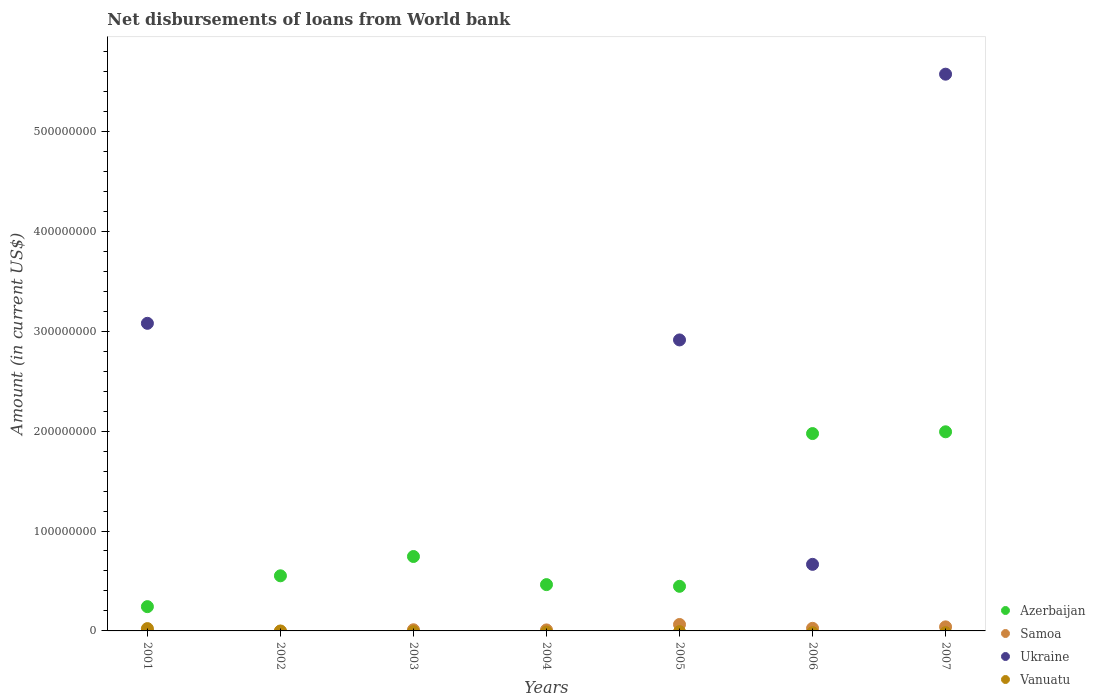What is the amount of loan disbursed from World Bank in Samoa in 2005?
Keep it short and to the point. 6.44e+06. Across all years, what is the maximum amount of loan disbursed from World Bank in Samoa?
Make the answer very short. 6.44e+06. Across all years, what is the minimum amount of loan disbursed from World Bank in Azerbaijan?
Your answer should be very brief. 2.43e+07. In which year was the amount of loan disbursed from World Bank in Vanuatu maximum?
Keep it short and to the point. 2001. What is the total amount of loan disbursed from World Bank in Vanuatu in the graph?
Offer a very short reply. 2.32e+06. What is the difference between the amount of loan disbursed from World Bank in Samoa in 2001 and that in 2007?
Provide a short and direct response. -3.95e+06. What is the difference between the amount of loan disbursed from World Bank in Samoa in 2006 and the amount of loan disbursed from World Bank in Vanuatu in 2001?
Ensure brevity in your answer.  2.75e+05. What is the average amount of loan disbursed from World Bank in Azerbaijan per year?
Make the answer very short. 9.17e+07. In the year 2001, what is the difference between the amount of loan disbursed from World Bank in Vanuatu and amount of loan disbursed from World Bank in Ukraine?
Give a very brief answer. -3.06e+08. In how many years, is the amount of loan disbursed from World Bank in Samoa greater than 360000000 US$?
Offer a terse response. 0. What is the ratio of the amount of loan disbursed from World Bank in Azerbaijan in 2004 to that in 2005?
Your answer should be compact. 1.04. What is the difference between the highest and the second highest amount of loan disbursed from World Bank in Azerbaijan?
Your answer should be compact. 1.77e+06. What is the difference between the highest and the lowest amount of loan disbursed from World Bank in Ukraine?
Provide a succinct answer. 5.57e+08. Is it the case that in every year, the sum of the amount of loan disbursed from World Bank in Ukraine and amount of loan disbursed from World Bank in Samoa  is greater than the sum of amount of loan disbursed from World Bank in Vanuatu and amount of loan disbursed from World Bank in Azerbaijan?
Offer a terse response. No. Is the amount of loan disbursed from World Bank in Samoa strictly less than the amount of loan disbursed from World Bank in Ukraine over the years?
Provide a short and direct response. No. How many dotlines are there?
Offer a terse response. 4. How many years are there in the graph?
Ensure brevity in your answer.  7. What is the difference between two consecutive major ticks on the Y-axis?
Your response must be concise. 1.00e+08. Where does the legend appear in the graph?
Give a very brief answer. Bottom right. How many legend labels are there?
Keep it short and to the point. 4. What is the title of the graph?
Your answer should be compact. Net disbursements of loans from World bank. Does "Guatemala" appear as one of the legend labels in the graph?
Keep it short and to the point. No. What is the label or title of the X-axis?
Keep it short and to the point. Years. What is the Amount (in current US$) of Azerbaijan in 2001?
Offer a terse response. 2.43e+07. What is the Amount (in current US$) of Samoa in 2001?
Give a very brief answer. 1.08e+05. What is the Amount (in current US$) in Ukraine in 2001?
Make the answer very short. 3.08e+08. What is the Amount (in current US$) of Vanuatu in 2001?
Provide a succinct answer. 2.32e+06. What is the Amount (in current US$) of Azerbaijan in 2002?
Keep it short and to the point. 5.52e+07. What is the Amount (in current US$) in Samoa in 2002?
Keep it short and to the point. 0. What is the Amount (in current US$) in Vanuatu in 2002?
Keep it short and to the point. 0. What is the Amount (in current US$) in Azerbaijan in 2003?
Keep it short and to the point. 7.45e+07. What is the Amount (in current US$) in Samoa in 2003?
Offer a very short reply. 1.15e+06. What is the Amount (in current US$) of Ukraine in 2003?
Provide a short and direct response. 0. What is the Amount (in current US$) in Vanuatu in 2003?
Make the answer very short. 0. What is the Amount (in current US$) in Azerbaijan in 2004?
Your answer should be very brief. 4.63e+07. What is the Amount (in current US$) in Samoa in 2004?
Your response must be concise. 1.01e+06. What is the Amount (in current US$) in Ukraine in 2004?
Give a very brief answer. 0. What is the Amount (in current US$) in Vanuatu in 2004?
Provide a short and direct response. 0. What is the Amount (in current US$) of Azerbaijan in 2005?
Give a very brief answer. 4.46e+07. What is the Amount (in current US$) in Samoa in 2005?
Offer a very short reply. 6.44e+06. What is the Amount (in current US$) of Ukraine in 2005?
Offer a terse response. 2.91e+08. What is the Amount (in current US$) in Azerbaijan in 2006?
Provide a succinct answer. 1.98e+08. What is the Amount (in current US$) of Samoa in 2006?
Make the answer very short. 2.60e+06. What is the Amount (in current US$) of Ukraine in 2006?
Your answer should be compact. 6.66e+07. What is the Amount (in current US$) of Vanuatu in 2006?
Your answer should be very brief. 0. What is the Amount (in current US$) of Azerbaijan in 2007?
Your response must be concise. 1.99e+08. What is the Amount (in current US$) in Samoa in 2007?
Your answer should be compact. 4.06e+06. What is the Amount (in current US$) of Ukraine in 2007?
Your answer should be compact. 5.57e+08. Across all years, what is the maximum Amount (in current US$) in Azerbaijan?
Your response must be concise. 1.99e+08. Across all years, what is the maximum Amount (in current US$) of Samoa?
Provide a succinct answer. 6.44e+06. Across all years, what is the maximum Amount (in current US$) in Ukraine?
Make the answer very short. 5.57e+08. Across all years, what is the maximum Amount (in current US$) in Vanuatu?
Provide a succinct answer. 2.32e+06. Across all years, what is the minimum Amount (in current US$) in Azerbaijan?
Your answer should be compact. 2.43e+07. Across all years, what is the minimum Amount (in current US$) in Vanuatu?
Make the answer very short. 0. What is the total Amount (in current US$) in Azerbaijan in the graph?
Ensure brevity in your answer.  6.42e+08. What is the total Amount (in current US$) of Samoa in the graph?
Offer a terse response. 1.54e+07. What is the total Amount (in current US$) of Ukraine in the graph?
Provide a short and direct response. 1.22e+09. What is the total Amount (in current US$) of Vanuatu in the graph?
Provide a succinct answer. 2.32e+06. What is the difference between the Amount (in current US$) in Azerbaijan in 2001 and that in 2002?
Your response must be concise. -3.09e+07. What is the difference between the Amount (in current US$) in Azerbaijan in 2001 and that in 2003?
Your answer should be compact. -5.02e+07. What is the difference between the Amount (in current US$) of Samoa in 2001 and that in 2003?
Offer a terse response. -1.04e+06. What is the difference between the Amount (in current US$) in Azerbaijan in 2001 and that in 2004?
Make the answer very short. -2.20e+07. What is the difference between the Amount (in current US$) of Samoa in 2001 and that in 2004?
Provide a succinct answer. -9.02e+05. What is the difference between the Amount (in current US$) in Azerbaijan in 2001 and that in 2005?
Offer a very short reply. -2.04e+07. What is the difference between the Amount (in current US$) in Samoa in 2001 and that in 2005?
Give a very brief answer. -6.34e+06. What is the difference between the Amount (in current US$) of Ukraine in 2001 and that in 2005?
Keep it short and to the point. 1.66e+07. What is the difference between the Amount (in current US$) of Azerbaijan in 2001 and that in 2006?
Provide a succinct answer. -1.73e+08. What is the difference between the Amount (in current US$) of Samoa in 2001 and that in 2006?
Your response must be concise. -2.49e+06. What is the difference between the Amount (in current US$) in Ukraine in 2001 and that in 2006?
Give a very brief answer. 2.41e+08. What is the difference between the Amount (in current US$) of Azerbaijan in 2001 and that in 2007?
Provide a succinct answer. -1.75e+08. What is the difference between the Amount (in current US$) in Samoa in 2001 and that in 2007?
Offer a terse response. -3.95e+06. What is the difference between the Amount (in current US$) in Ukraine in 2001 and that in 2007?
Make the answer very short. -2.49e+08. What is the difference between the Amount (in current US$) in Azerbaijan in 2002 and that in 2003?
Make the answer very short. -1.93e+07. What is the difference between the Amount (in current US$) of Azerbaijan in 2002 and that in 2004?
Provide a short and direct response. 8.82e+06. What is the difference between the Amount (in current US$) of Azerbaijan in 2002 and that in 2005?
Give a very brief answer. 1.05e+07. What is the difference between the Amount (in current US$) of Azerbaijan in 2002 and that in 2006?
Your answer should be compact. -1.42e+08. What is the difference between the Amount (in current US$) of Azerbaijan in 2002 and that in 2007?
Your answer should be very brief. -1.44e+08. What is the difference between the Amount (in current US$) of Azerbaijan in 2003 and that in 2004?
Provide a succinct answer. 2.81e+07. What is the difference between the Amount (in current US$) in Samoa in 2003 and that in 2004?
Give a very brief answer. 1.39e+05. What is the difference between the Amount (in current US$) of Azerbaijan in 2003 and that in 2005?
Offer a terse response. 2.98e+07. What is the difference between the Amount (in current US$) of Samoa in 2003 and that in 2005?
Your response must be concise. -5.30e+06. What is the difference between the Amount (in current US$) of Azerbaijan in 2003 and that in 2006?
Your response must be concise. -1.23e+08. What is the difference between the Amount (in current US$) in Samoa in 2003 and that in 2006?
Your answer should be very brief. -1.45e+06. What is the difference between the Amount (in current US$) in Azerbaijan in 2003 and that in 2007?
Offer a terse response. -1.25e+08. What is the difference between the Amount (in current US$) of Samoa in 2003 and that in 2007?
Offer a very short reply. -2.91e+06. What is the difference between the Amount (in current US$) of Azerbaijan in 2004 and that in 2005?
Ensure brevity in your answer.  1.70e+06. What is the difference between the Amount (in current US$) of Samoa in 2004 and that in 2005?
Offer a very short reply. -5.44e+06. What is the difference between the Amount (in current US$) in Azerbaijan in 2004 and that in 2006?
Your answer should be very brief. -1.51e+08. What is the difference between the Amount (in current US$) in Samoa in 2004 and that in 2006?
Offer a very short reply. -1.58e+06. What is the difference between the Amount (in current US$) in Azerbaijan in 2004 and that in 2007?
Your answer should be compact. -1.53e+08. What is the difference between the Amount (in current US$) of Samoa in 2004 and that in 2007?
Make the answer very short. -3.05e+06. What is the difference between the Amount (in current US$) in Azerbaijan in 2005 and that in 2006?
Your answer should be very brief. -1.53e+08. What is the difference between the Amount (in current US$) of Samoa in 2005 and that in 2006?
Your response must be concise. 3.85e+06. What is the difference between the Amount (in current US$) of Ukraine in 2005 and that in 2006?
Your answer should be compact. 2.25e+08. What is the difference between the Amount (in current US$) in Azerbaijan in 2005 and that in 2007?
Give a very brief answer. -1.55e+08. What is the difference between the Amount (in current US$) in Samoa in 2005 and that in 2007?
Your response must be concise. 2.39e+06. What is the difference between the Amount (in current US$) of Ukraine in 2005 and that in 2007?
Keep it short and to the point. -2.66e+08. What is the difference between the Amount (in current US$) in Azerbaijan in 2006 and that in 2007?
Your response must be concise. -1.77e+06. What is the difference between the Amount (in current US$) of Samoa in 2006 and that in 2007?
Provide a short and direct response. -1.46e+06. What is the difference between the Amount (in current US$) of Ukraine in 2006 and that in 2007?
Your answer should be very brief. -4.91e+08. What is the difference between the Amount (in current US$) of Azerbaijan in 2001 and the Amount (in current US$) of Samoa in 2003?
Give a very brief answer. 2.31e+07. What is the difference between the Amount (in current US$) of Azerbaijan in 2001 and the Amount (in current US$) of Samoa in 2004?
Give a very brief answer. 2.33e+07. What is the difference between the Amount (in current US$) of Azerbaijan in 2001 and the Amount (in current US$) of Samoa in 2005?
Keep it short and to the point. 1.79e+07. What is the difference between the Amount (in current US$) in Azerbaijan in 2001 and the Amount (in current US$) in Ukraine in 2005?
Make the answer very short. -2.67e+08. What is the difference between the Amount (in current US$) in Samoa in 2001 and the Amount (in current US$) in Ukraine in 2005?
Your response must be concise. -2.91e+08. What is the difference between the Amount (in current US$) of Azerbaijan in 2001 and the Amount (in current US$) of Samoa in 2006?
Offer a terse response. 2.17e+07. What is the difference between the Amount (in current US$) of Azerbaijan in 2001 and the Amount (in current US$) of Ukraine in 2006?
Keep it short and to the point. -4.23e+07. What is the difference between the Amount (in current US$) of Samoa in 2001 and the Amount (in current US$) of Ukraine in 2006?
Give a very brief answer. -6.65e+07. What is the difference between the Amount (in current US$) of Azerbaijan in 2001 and the Amount (in current US$) of Samoa in 2007?
Provide a short and direct response. 2.02e+07. What is the difference between the Amount (in current US$) in Azerbaijan in 2001 and the Amount (in current US$) in Ukraine in 2007?
Provide a short and direct response. -5.33e+08. What is the difference between the Amount (in current US$) in Samoa in 2001 and the Amount (in current US$) in Ukraine in 2007?
Your response must be concise. -5.57e+08. What is the difference between the Amount (in current US$) of Azerbaijan in 2002 and the Amount (in current US$) of Samoa in 2003?
Ensure brevity in your answer.  5.40e+07. What is the difference between the Amount (in current US$) of Azerbaijan in 2002 and the Amount (in current US$) of Samoa in 2004?
Provide a short and direct response. 5.42e+07. What is the difference between the Amount (in current US$) in Azerbaijan in 2002 and the Amount (in current US$) in Samoa in 2005?
Provide a short and direct response. 4.87e+07. What is the difference between the Amount (in current US$) in Azerbaijan in 2002 and the Amount (in current US$) in Ukraine in 2005?
Provide a short and direct response. -2.36e+08. What is the difference between the Amount (in current US$) of Azerbaijan in 2002 and the Amount (in current US$) of Samoa in 2006?
Make the answer very short. 5.26e+07. What is the difference between the Amount (in current US$) in Azerbaijan in 2002 and the Amount (in current US$) in Ukraine in 2006?
Provide a succinct answer. -1.15e+07. What is the difference between the Amount (in current US$) in Azerbaijan in 2002 and the Amount (in current US$) in Samoa in 2007?
Your answer should be very brief. 5.11e+07. What is the difference between the Amount (in current US$) of Azerbaijan in 2002 and the Amount (in current US$) of Ukraine in 2007?
Give a very brief answer. -5.02e+08. What is the difference between the Amount (in current US$) of Azerbaijan in 2003 and the Amount (in current US$) of Samoa in 2004?
Provide a short and direct response. 7.35e+07. What is the difference between the Amount (in current US$) in Azerbaijan in 2003 and the Amount (in current US$) in Samoa in 2005?
Give a very brief answer. 6.80e+07. What is the difference between the Amount (in current US$) of Azerbaijan in 2003 and the Amount (in current US$) of Ukraine in 2005?
Give a very brief answer. -2.17e+08. What is the difference between the Amount (in current US$) in Samoa in 2003 and the Amount (in current US$) in Ukraine in 2005?
Offer a very short reply. -2.90e+08. What is the difference between the Amount (in current US$) of Azerbaijan in 2003 and the Amount (in current US$) of Samoa in 2006?
Provide a succinct answer. 7.19e+07. What is the difference between the Amount (in current US$) of Azerbaijan in 2003 and the Amount (in current US$) of Ukraine in 2006?
Ensure brevity in your answer.  7.86e+06. What is the difference between the Amount (in current US$) in Samoa in 2003 and the Amount (in current US$) in Ukraine in 2006?
Ensure brevity in your answer.  -6.55e+07. What is the difference between the Amount (in current US$) in Azerbaijan in 2003 and the Amount (in current US$) in Samoa in 2007?
Provide a succinct answer. 7.04e+07. What is the difference between the Amount (in current US$) of Azerbaijan in 2003 and the Amount (in current US$) of Ukraine in 2007?
Your answer should be very brief. -4.83e+08. What is the difference between the Amount (in current US$) in Samoa in 2003 and the Amount (in current US$) in Ukraine in 2007?
Make the answer very short. -5.56e+08. What is the difference between the Amount (in current US$) of Azerbaijan in 2004 and the Amount (in current US$) of Samoa in 2005?
Offer a terse response. 3.99e+07. What is the difference between the Amount (in current US$) of Azerbaijan in 2004 and the Amount (in current US$) of Ukraine in 2005?
Your response must be concise. -2.45e+08. What is the difference between the Amount (in current US$) in Samoa in 2004 and the Amount (in current US$) in Ukraine in 2005?
Give a very brief answer. -2.90e+08. What is the difference between the Amount (in current US$) in Azerbaijan in 2004 and the Amount (in current US$) in Samoa in 2006?
Your response must be concise. 4.37e+07. What is the difference between the Amount (in current US$) of Azerbaijan in 2004 and the Amount (in current US$) of Ukraine in 2006?
Your answer should be compact. -2.03e+07. What is the difference between the Amount (in current US$) of Samoa in 2004 and the Amount (in current US$) of Ukraine in 2006?
Your response must be concise. -6.56e+07. What is the difference between the Amount (in current US$) of Azerbaijan in 2004 and the Amount (in current US$) of Samoa in 2007?
Offer a very short reply. 4.23e+07. What is the difference between the Amount (in current US$) of Azerbaijan in 2004 and the Amount (in current US$) of Ukraine in 2007?
Keep it short and to the point. -5.11e+08. What is the difference between the Amount (in current US$) in Samoa in 2004 and the Amount (in current US$) in Ukraine in 2007?
Provide a short and direct response. -5.56e+08. What is the difference between the Amount (in current US$) of Azerbaijan in 2005 and the Amount (in current US$) of Samoa in 2006?
Make the answer very short. 4.21e+07. What is the difference between the Amount (in current US$) in Azerbaijan in 2005 and the Amount (in current US$) in Ukraine in 2006?
Make the answer very short. -2.20e+07. What is the difference between the Amount (in current US$) of Samoa in 2005 and the Amount (in current US$) of Ukraine in 2006?
Ensure brevity in your answer.  -6.02e+07. What is the difference between the Amount (in current US$) of Azerbaijan in 2005 and the Amount (in current US$) of Samoa in 2007?
Provide a short and direct response. 4.06e+07. What is the difference between the Amount (in current US$) in Azerbaijan in 2005 and the Amount (in current US$) in Ukraine in 2007?
Your response must be concise. -5.13e+08. What is the difference between the Amount (in current US$) in Samoa in 2005 and the Amount (in current US$) in Ukraine in 2007?
Keep it short and to the point. -5.51e+08. What is the difference between the Amount (in current US$) in Azerbaijan in 2006 and the Amount (in current US$) in Samoa in 2007?
Your answer should be compact. 1.93e+08. What is the difference between the Amount (in current US$) of Azerbaijan in 2006 and the Amount (in current US$) of Ukraine in 2007?
Provide a short and direct response. -3.60e+08. What is the difference between the Amount (in current US$) in Samoa in 2006 and the Amount (in current US$) in Ukraine in 2007?
Provide a succinct answer. -5.55e+08. What is the average Amount (in current US$) in Azerbaijan per year?
Offer a very short reply. 9.17e+07. What is the average Amount (in current US$) in Samoa per year?
Your answer should be very brief. 2.19e+06. What is the average Amount (in current US$) of Ukraine per year?
Your response must be concise. 1.75e+08. What is the average Amount (in current US$) of Vanuatu per year?
Ensure brevity in your answer.  3.31e+05. In the year 2001, what is the difference between the Amount (in current US$) in Azerbaijan and Amount (in current US$) in Samoa?
Provide a succinct answer. 2.42e+07. In the year 2001, what is the difference between the Amount (in current US$) of Azerbaijan and Amount (in current US$) of Ukraine?
Ensure brevity in your answer.  -2.84e+08. In the year 2001, what is the difference between the Amount (in current US$) in Azerbaijan and Amount (in current US$) in Vanuatu?
Your answer should be very brief. 2.20e+07. In the year 2001, what is the difference between the Amount (in current US$) of Samoa and Amount (in current US$) of Ukraine?
Give a very brief answer. -3.08e+08. In the year 2001, what is the difference between the Amount (in current US$) in Samoa and Amount (in current US$) in Vanuatu?
Provide a short and direct response. -2.21e+06. In the year 2001, what is the difference between the Amount (in current US$) in Ukraine and Amount (in current US$) in Vanuatu?
Your answer should be compact. 3.06e+08. In the year 2003, what is the difference between the Amount (in current US$) in Azerbaijan and Amount (in current US$) in Samoa?
Offer a terse response. 7.33e+07. In the year 2004, what is the difference between the Amount (in current US$) in Azerbaijan and Amount (in current US$) in Samoa?
Provide a succinct answer. 4.53e+07. In the year 2005, what is the difference between the Amount (in current US$) in Azerbaijan and Amount (in current US$) in Samoa?
Offer a terse response. 3.82e+07. In the year 2005, what is the difference between the Amount (in current US$) of Azerbaijan and Amount (in current US$) of Ukraine?
Keep it short and to the point. -2.47e+08. In the year 2005, what is the difference between the Amount (in current US$) of Samoa and Amount (in current US$) of Ukraine?
Your answer should be compact. -2.85e+08. In the year 2006, what is the difference between the Amount (in current US$) of Azerbaijan and Amount (in current US$) of Samoa?
Your response must be concise. 1.95e+08. In the year 2006, what is the difference between the Amount (in current US$) in Azerbaijan and Amount (in current US$) in Ukraine?
Your answer should be very brief. 1.31e+08. In the year 2006, what is the difference between the Amount (in current US$) in Samoa and Amount (in current US$) in Ukraine?
Offer a terse response. -6.40e+07. In the year 2007, what is the difference between the Amount (in current US$) of Azerbaijan and Amount (in current US$) of Samoa?
Your response must be concise. 1.95e+08. In the year 2007, what is the difference between the Amount (in current US$) in Azerbaijan and Amount (in current US$) in Ukraine?
Make the answer very short. -3.58e+08. In the year 2007, what is the difference between the Amount (in current US$) in Samoa and Amount (in current US$) in Ukraine?
Your response must be concise. -5.53e+08. What is the ratio of the Amount (in current US$) in Azerbaijan in 2001 to that in 2002?
Ensure brevity in your answer.  0.44. What is the ratio of the Amount (in current US$) in Azerbaijan in 2001 to that in 2003?
Your answer should be compact. 0.33. What is the ratio of the Amount (in current US$) of Samoa in 2001 to that in 2003?
Your answer should be compact. 0.09. What is the ratio of the Amount (in current US$) of Azerbaijan in 2001 to that in 2004?
Provide a succinct answer. 0.52. What is the ratio of the Amount (in current US$) of Samoa in 2001 to that in 2004?
Offer a terse response. 0.11. What is the ratio of the Amount (in current US$) of Azerbaijan in 2001 to that in 2005?
Offer a terse response. 0.54. What is the ratio of the Amount (in current US$) in Samoa in 2001 to that in 2005?
Your answer should be very brief. 0.02. What is the ratio of the Amount (in current US$) of Ukraine in 2001 to that in 2005?
Provide a short and direct response. 1.06. What is the ratio of the Amount (in current US$) in Azerbaijan in 2001 to that in 2006?
Give a very brief answer. 0.12. What is the ratio of the Amount (in current US$) of Samoa in 2001 to that in 2006?
Offer a very short reply. 0.04. What is the ratio of the Amount (in current US$) of Ukraine in 2001 to that in 2006?
Your answer should be very brief. 4.62. What is the ratio of the Amount (in current US$) of Azerbaijan in 2001 to that in 2007?
Provide a succinct answer. 0.12. What is the ratio of the Amount (in current US$) of Samoa in 2001 to that in 2007?
Ensure brevity in your answer.  0.03. What is the ratio of the Amount (in current US$) of Ukraine in 2001 to that in 2007?
Your answer should be compact. 0.55. What is the ratio of the Amount (in current US$) in Azerbaijan in 2002 to that in 2003?
Offer a very short reply. 0.74. What is the ratio of the Amount (in current US$) in Azerbaijan in 2002 to that in 2004?
Your response must be concise. 1.19. What is the ratio of the Amount (in current US$) of Azerbaijan in 2002 to that in 2005?
Your answer should be very brief. 1.24. What is the ratio of the Amount (in current US$) in Azerbaijan in 2002 to that in 2006?
Ensure brevity in your answer.  0.28. What is the ratio of the Amount (in current US$) of Azerbaijan in 2002 to that in 2007?
Your response must be concise. 0.28. What is the ratio of the Amount (in current US$) of Azerbaijan in 2003 to that in 2004?
Keep it short and to the point. 1.61. What is the ratio of the Amount (in current US$) in Samoa in 2003 to that in 2004?
Your response must be concise. 1.14. What is the ratio of the Amount (in current US$) of Azerbaijan in 2003 to that in 2005?
Give a very brief answer. 1.67. What is the ratio of the Amount (in current US$) of Samoa in 2003 to that in 2005?
Your answer should be compact. 0.18. What is the ratio of the Amount (in current US$) in Azerbaijan in 2003 to that in 2006?
Make the answer very short. 0.38. What is the ratio of the Amount (in current US$) of Samoa in 2003 to that in 2006?
Offer a very short reply. 0.44. What is the ratio of the Amount (in current US$) in Azerbaijan in 2003 to that in 2007?
Make the answer very short. 0.37. What is the ratio of the Amount (in current US$) in Samoa in 2003 to that in 2007?
Offer a terse response. 0.28. What is the ratio of the Amount (in current US$) of Azerbaijan in 2004 to that in 2005?
Make the answer very short. 1.04. What is the ratio of the Amount (in current US$) of Samoa in 2004 to that in 2005?
Your response must be concise. 0.16. What is the ratio of the Amount (in current US$) of Azerbaijan in 2004 to that in 2006?
Provide a succinct answer. 0.23. What is the ratio of the Amount (in current US$) of Samoa in 2004 to that in 2006?
Make the answer very short. 0.39. What is the ratio of the Amount (in current US$) of Azerbaijan in 2004 to that in 2007?
Provide a succinct answer. 0.23. What is the ratio of the Amount (in current US$) of Samoa in 2004 to that in 2007?
Make the answer very short. 0.25. What is the ratio of the Amount (in current US$) of Azerbaijan in 2005 to that in 2006?
Give a very brief answer. 0.23. What is the ratio of the Amount (in current US$) in Samoa in 2005 to that in 2006?
Provide a short and direct response. 2.48. What is the ratio of the Amount (in current US$) of Ukraine in 2005 to that in 2006?
Offer a terse response. 4.37. What is the ratio of the Amount (in current US$) of Azerbaijan in 2005 to that in 2007?
Provide a succinct answer. 0.22. What is the ratio of the Amount (in current US$) in Samoa in 2005 to that in 2007?
Your answer should be compact. 1.59. What is the ratio of the Amount (in current US$) of Ukraine in 2005 to that in 2007?
Your response must be concise. 0.52. What is the ratio of the Amount (in current US$) of Samoa in 2006 to that in 2007?
Your response must be concise. 0.64. What is the ratio of the Amount (in current US$) in Ukraine in 2006 to that in 2007?
Ensure brevity in your answer.  0.12. What is the difference between the highest and the second highest Amount (in current US$) in Azerbaijan?
Ensure brevity in your answer.  1.77e+06. What is the difference between the highest and the second highest Amount (in current US$) in Samoa?
Make the answer very short. 2.39e+06. What is the difference between the highest and the second highest Amount (in current US$) in Ukraine?
Give a very brief answer. 2.49e+08. What is the difference between the highest and the lowest Amount (in current US$) of Azerbaijan?
Offer a very short reply. 1.75e+08. What is the difference between the highest and the lowest Amount (in current US$) in Samoa?
Make the answer very short. 6.44e+06. What is the difference between the highest and the lowest Amount (in current US$) in Ukraine?
Ensure brevity in your answer.  5.57e+08. What is the difference between the highest and the lowest Amount (in current US$) of Vanuatu?
Ensure brevity in your answer.  2.32e+06. 